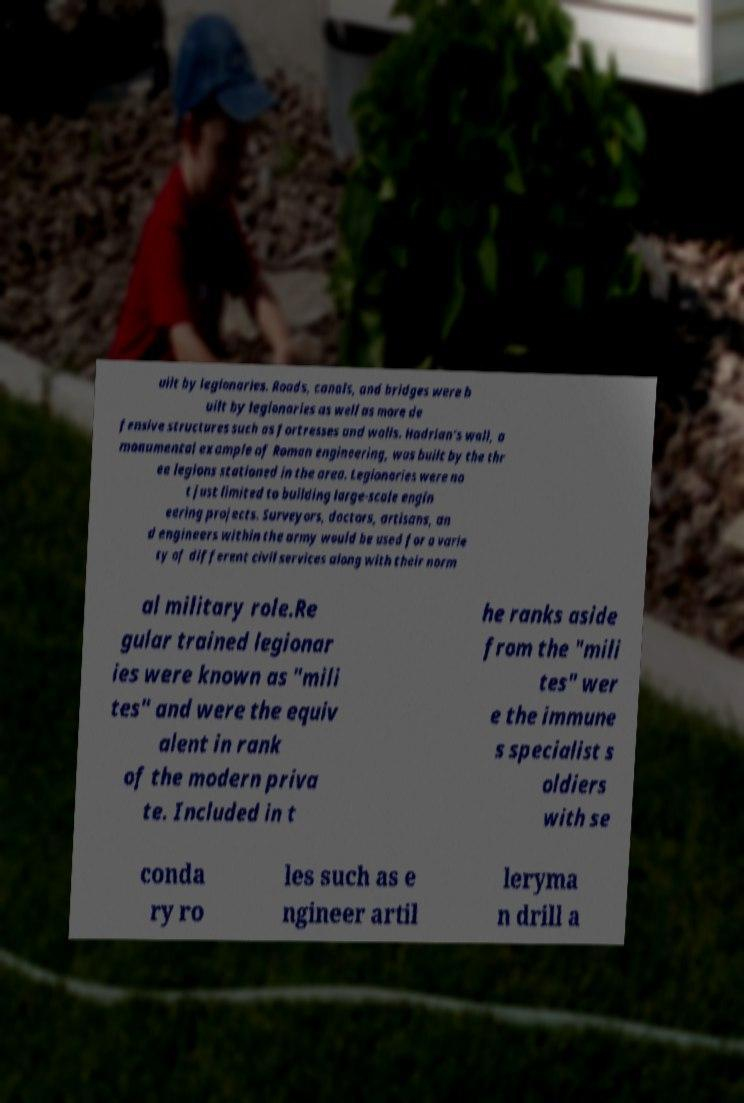What messages or text are displayed in this image? I need them in a readable, typed format. uilt by legionaries. Roads, canals, and bridges were b uilt by legionaries as well as more de fensive structures such as fortresses and walls. Hadrian's wall, a monumental example of Roman engineering, was built by the thr ee legions stationed in the area. Legionaries were no t just limited to building large-scale engin eering projects. Surveyors, doctors, artisans, an d engineers within the army would be used for a varie ty of different civil services along with their norm al military role.Re gular trained legionar ies were known as "mili tes" and were the equiv alent in rank of the modern priva te. Included in t he ranks aside from the "mili tes" wer e the immune s specialist s oldiers with se conda ry ro les such as e ngineer artil leryma n drill a 